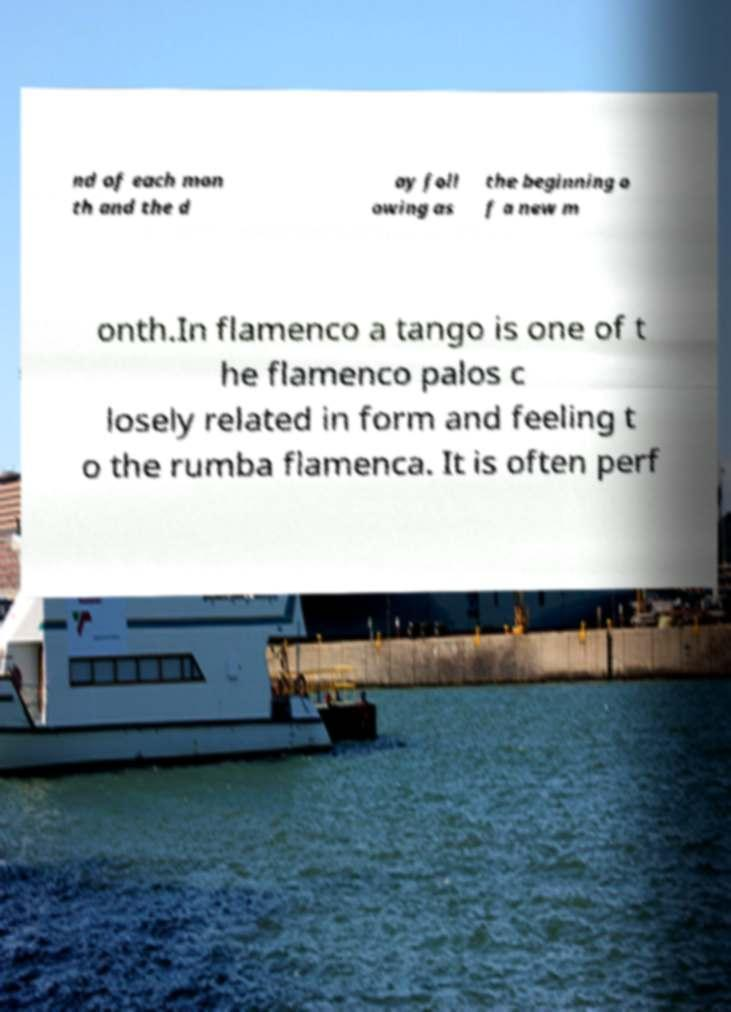Could you extract and type out the text from this image? nd of each mon th and the d ay foll owing as the beginning o f a new m onth.In flamenco a tango is one of t he flamenco palos c losely related in form and feeling t o the rumba flamenca. It is often perf 